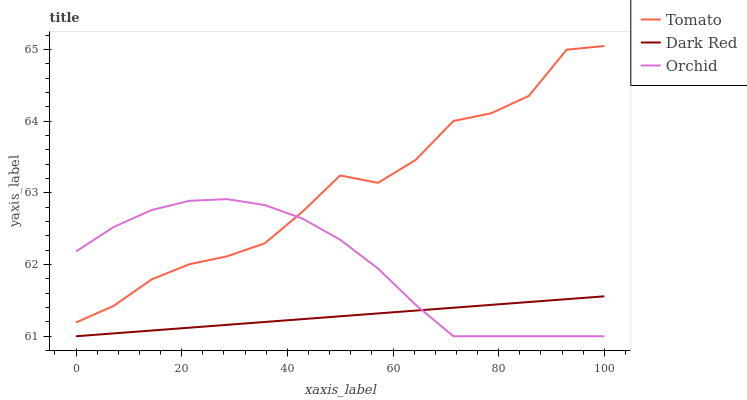Does Dark Red have the minimum area under the curve?
Answer yes or no. Yes. Does Tomato have the maximum area under the curve?
Answer yes or no. Yes. Does Orchid have the minimum area under the curve?
Answer yes or no. No. Does Orchid have the maximum area under the curve?
Answer yes or no. No. Is Dark Red the smoothest?
Answer yes or no. Yes. Is Tomato the roughest?
Answer yes or no. Yes. Is Orchid the smoothest?
Answer yes or no. No. Is Orchid the roughest?
Answer yes or no. No. Does Dark Red have the lowest value?
Answer yes or no. Yes. Does Tomato have the highest value?
Answer yes or no. Yes. Does Orchid have the highest value?
Answer yes or no. No. Is Dark Red less than Tomato?
Answer yes or no. Yes. Is Tomato greater than Dark Red?
Answer yes or no. Yes. Does Dark Red intersect Orchid?
Answer yes or no. Yes. Is Dark Red less than Orchid?
Answer yes or no. No. Is Dark Red greater than Orchid?
Answer yes or no. No. Does Dark Red intersect Tomato?
Answer yes or no. No. 